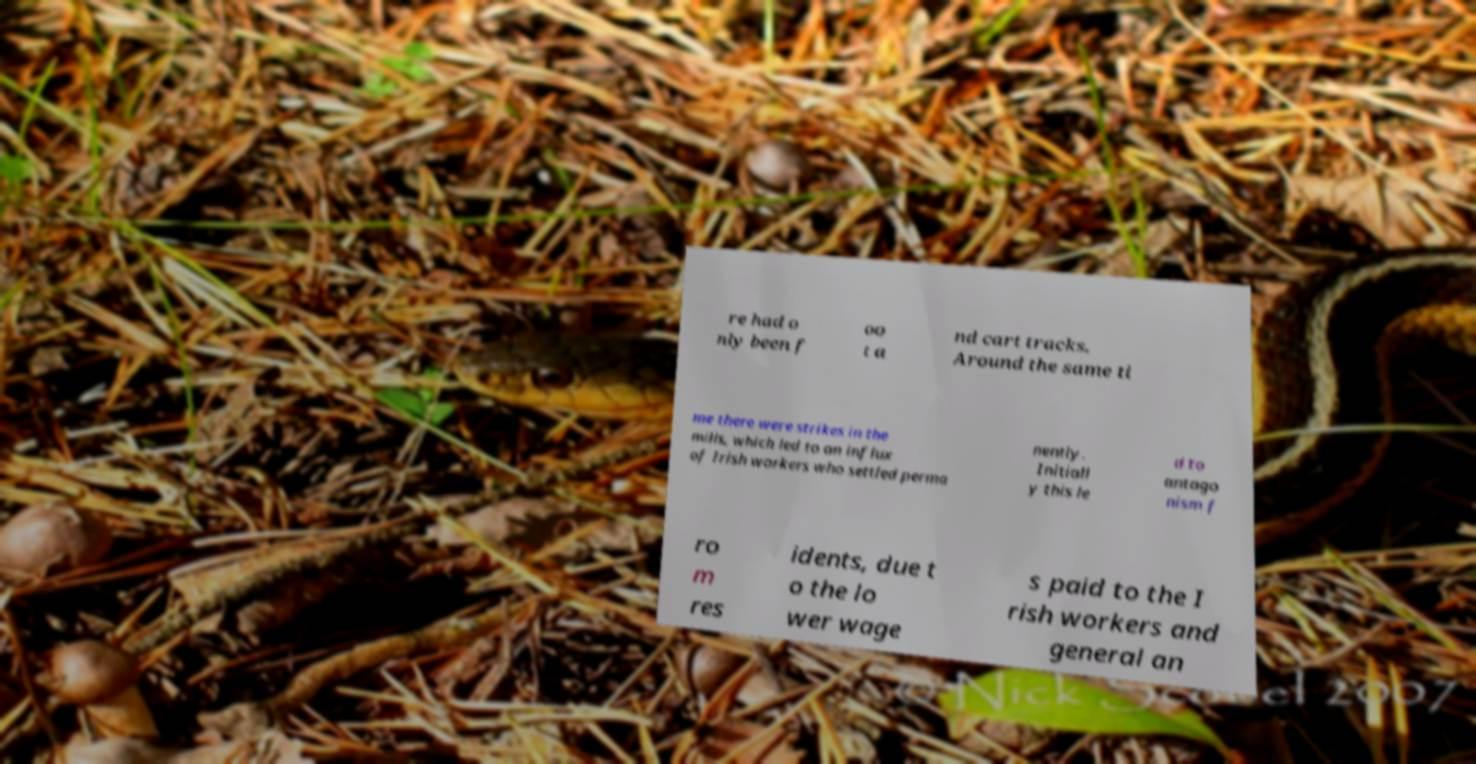Please identify and transcribe the text found in this image. re had o nly been f oo t a nd cart tracks. Around the same ti me there were strikes in the mills, which led to an influx of Irish workers who settled perma nently. Initiall y this le d to antago nism f ro m res idents, due t o the lo wer wage s paid to the I rish workers and general an 